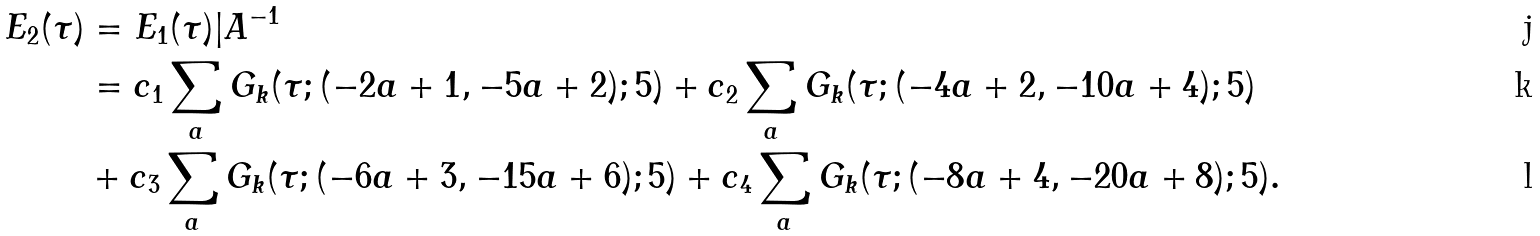Convert formula to latex. <formula><loc_0><loc_0><loc_500><loc_500>E _ { 2 } ( \tau ) & = E _ { 1 } ( \tau ) | A ^ { - 1 } \\ & = c _ { 1 } \sum _ { a } G _ { k } ( \tau ; ( - 2 a + 1 , - 5 a + 2 ) ; 5 ) + c _ { 2 } \sum _ { a } G _ { k } ( \tau ; ( - 4 a + 2 , - 1 0 a + 4 ) ; 5 ) \\ & + c _ { 3 } \sum _ { a } G _ { k } ( \tau ; ( - 6 a + 3 , - 1 5 a + 6 ) ; 5 ) + c _ { 4 } \sum _ { a } G _ { k } ( \tau ; ( - 8 a + 4 , - 2 0 a + 8 ) ; 5 ) .</formula> 